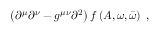<formula> <loc_0><loc_0><loc_500><loc_500>\left ( \partial ^ { \mu } \partial ^ { \nu } - g ^ { \mu \nu } \partial ^ { 2 } \right ) f \left ( A , \omega , \bar { \omega } \right ) \, ,</formula> 